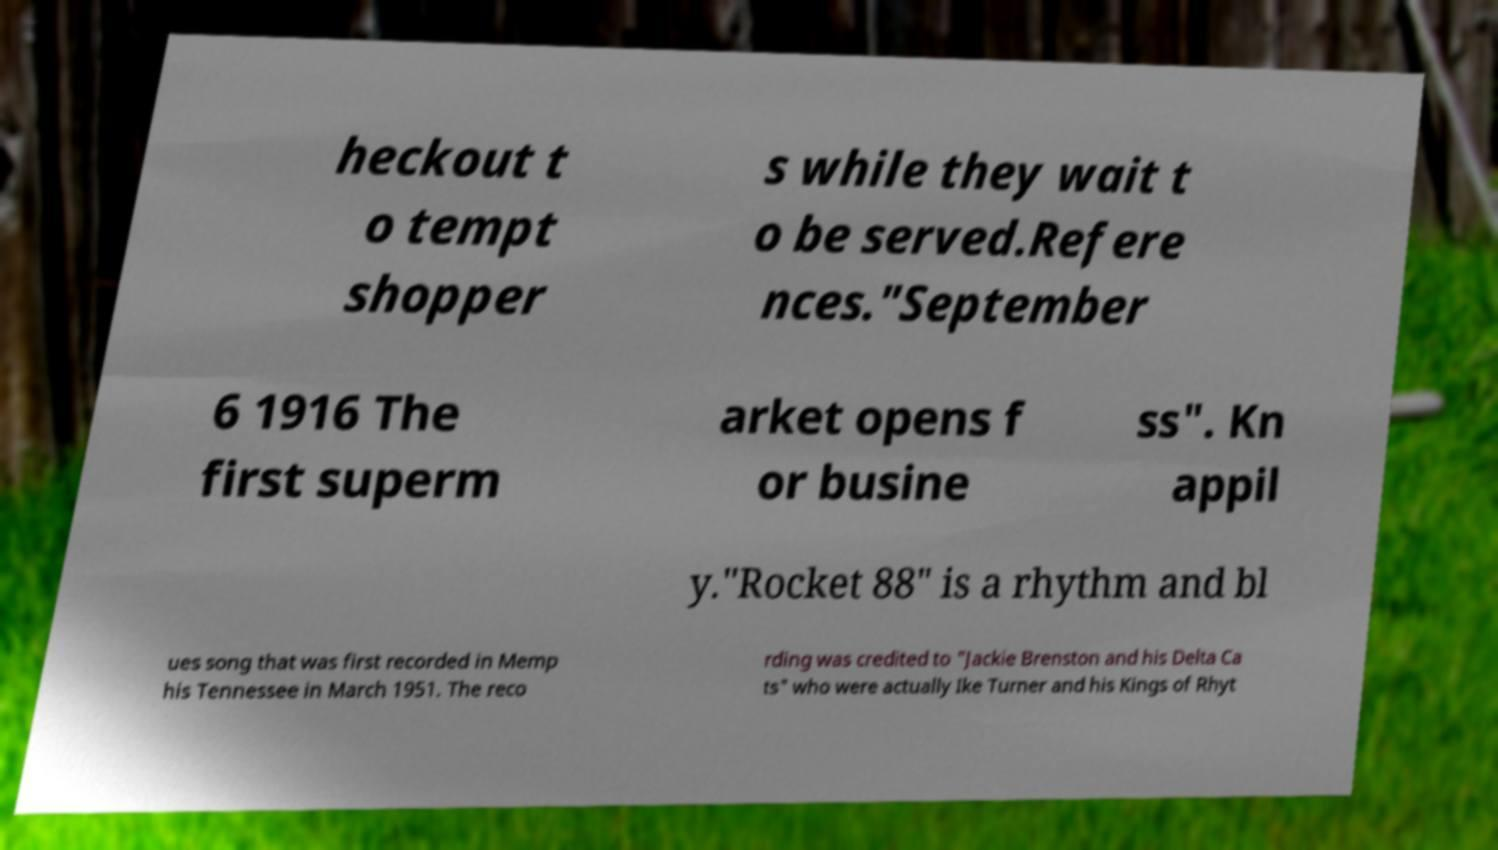Please identify and transcribe the text found in this image. heckout t o tempt shopper s while they wait t o be served.Refere nces."September 6 1916 The first superm arket opens f or busine ss". Kn appil y."Rocket 88" is a rhythm and bl ues song that was first recorded in Memp his Tennessee in March 1951. The reco rding was credited to "Jackie Brenston and his Delta Ca ts" who were actually Ike Turner and his Kings of Rhyt 